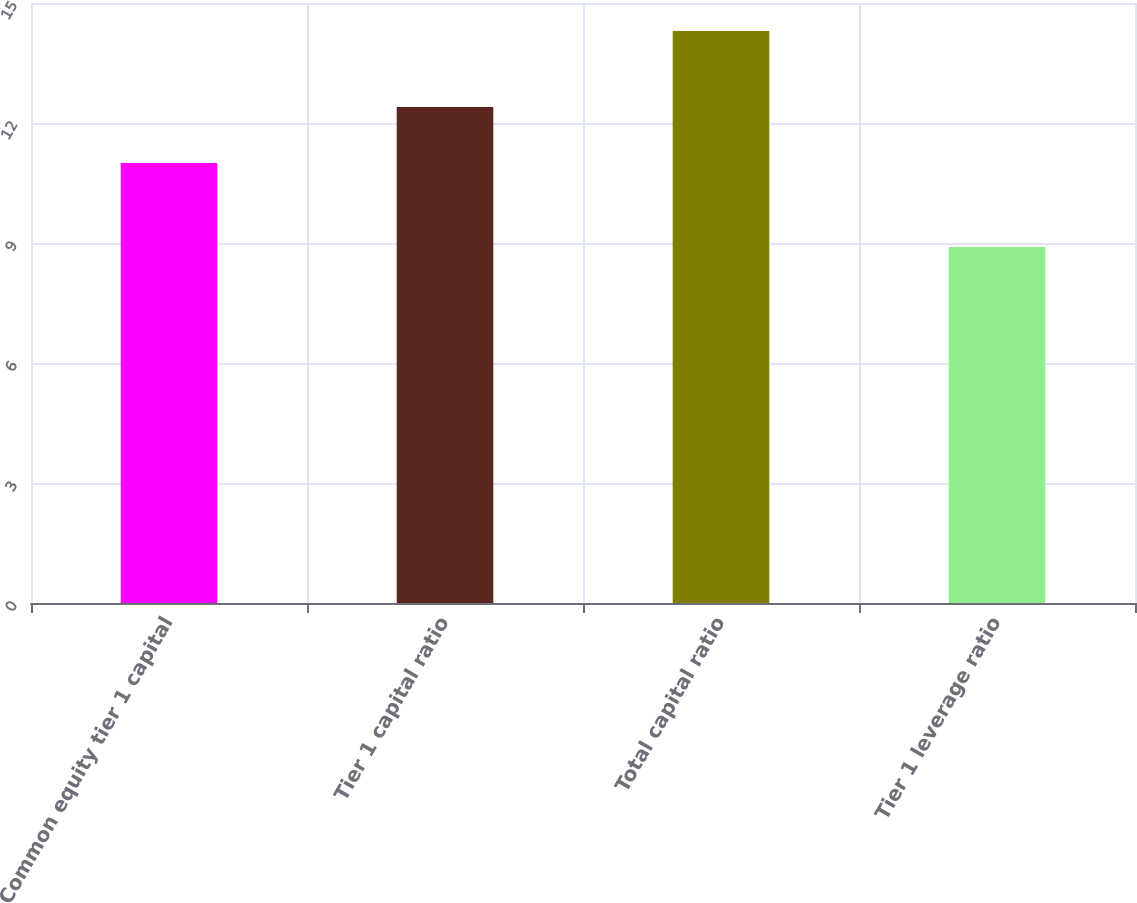<chart> <loc_0><loc_0><loc_500><loc_500><bar_chart><fcel>Common equity tier 1 capital<fcel>Tier 1 capital ratio<fcel>Total capital ratio<fcel>Tier 1 leverage ratio<nl><fcel>11<fcel>12.4<fcel>14.3<fcel>8.9<nl></chart> 